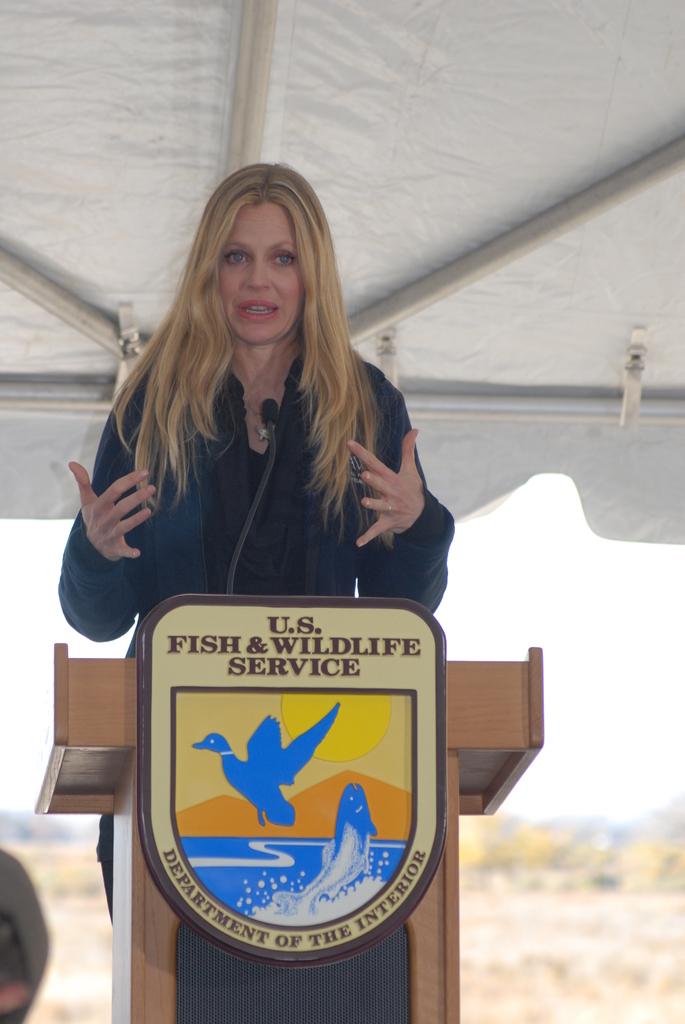What kind of service is this woman speaking for?
Provide a succinct answer. Fish and wildlife. What type of service is this?
Ensure brevity in your answer.  Fish and wildlife. 